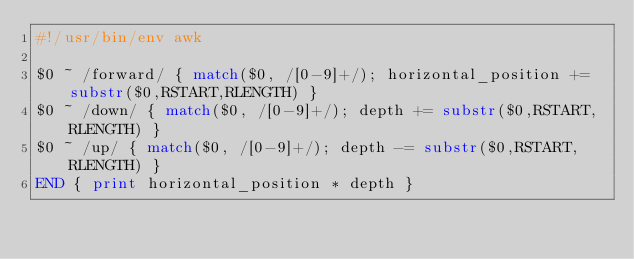<code> <loc_0><loc_0><loc_500><loc_500><_Awk_>#!/usr/bin/env awk

$0 ~ /forward/ { match($0, /[0-9]+/); horizontal_position += substr($0,RSTART,RLENGTH) } 
$0 ~ /down/ { match($0, /[0-9]+/); depth += substr($0,RSTART,RLENGTH) }
$0 ~ /up/ { match($0, /[0-9]+/); depth -= substr($0,RSTART,RLENGTH) }
END { print horizontal_position * depth }
</code> 